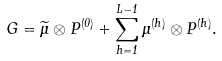<formula> <loc_0><loc_0><loc_500><loc_500>G = { \widetilde { \mu } } \otimes P ^ { ( 0 ) } + \sum _ { h = 1 } ^ { L - 1 } \mu ^ { ( h ) } \otimes P ^ { ( h ) } .</formula> 